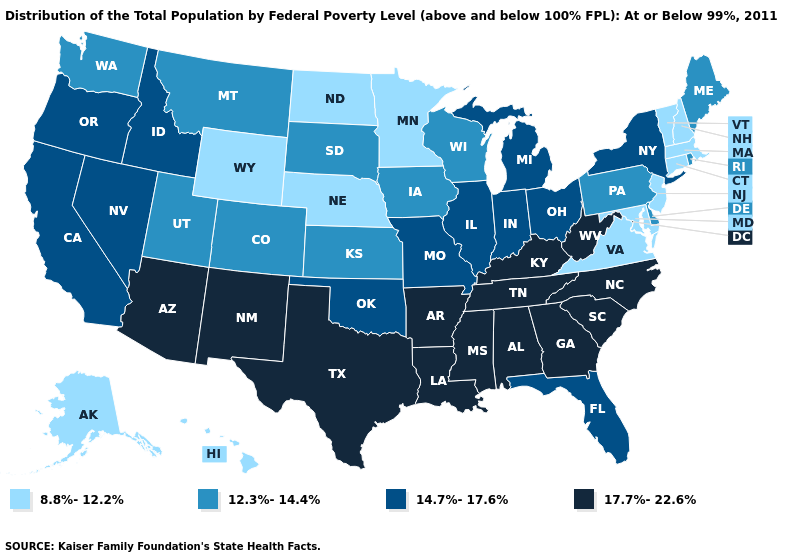Name the states that have a value in the range 8.8%-12.2%?
Answer briefly. Alaska, Connecticut, Hawaii, Maryland, Massachusetts, Minnesota, Nebraska, New Hampshire, New Jersey, North Dakota, Vermont, Virginia, Wyoming. Does Oklahoma have a higher value than Nevada?
Concise answer only. No. Which states have the lowest value in the USA?
Concise answer only. Alaska, Connecticut, Hawaii, Maryland, Massachusetts, Minnesota, Nebraska, New Hampshire, New Jersey, North Dakota, Vermont, Virginia, Wyoming. What is the highest value in the South ?
Be succinct. 17.7%-22.6%. Does Florida have the same value as Indiana?
Give a very brief answer. Yes. What is the lowest value in states that border Nevada?
Concise answer only. 12.3%-14.4%. What is the value of Oregon?
Quick response, please. 14.7%-17.6%. Name the states that have a value in the range 17.7%-22.6%?
Quick response, please. Alabama, Arizona, Arkansas, Georgia, Kentucky, Louisiana, Mississippi, New Mexico, North Carolina, South Carolina, Tennessee, Texas, West Virginia. What is the value of Rhode Island?
Keep it brief. 12.3%-14.4%. What is the lowest value in the South?
Concise answer only. 8.8%-12.2%. What is the value of Maine?
Write a very short answer. 12.3%-14.4%. What is the value of Florida?
Answer briefly. 14.7%-17.6%. What is the value of Wisconsin?
Write a very short answer. 12.3%-14.4%. Does Kentucky have the lowest value in the USA?
Answer briefly. No. Which states hav the highest value in the West?
Write a very short answer. Arizona, New Mexico. 